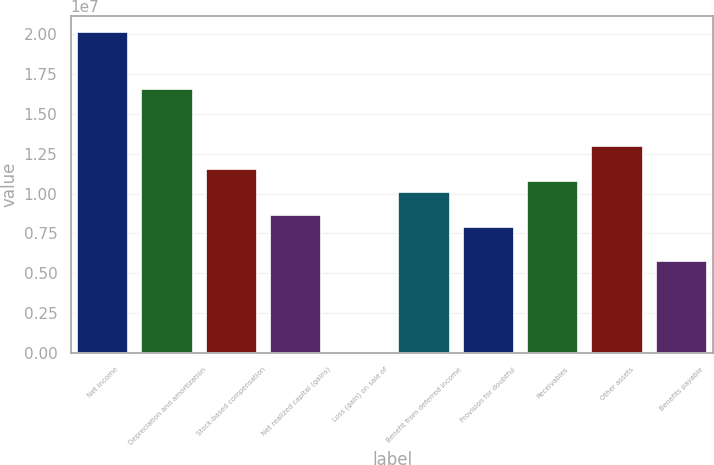Convert chart. <chart><loc_0><loc_0><loc_500><loc_500><bar_chart><fcel>Net income<fcel>Depreciation and amortization<fcel>Stock-based compensation<fcel>Net realized capital (gains)<fcel>Loss (gain) on sale of<fcel>Benefit from deferred income<fcel>Provision for doubtful<fcel>Receivables<fcel>Other assets<fcel>Benefits payable<nl><fcel>2.01512e+07<fcel>1.65528e+07<fcel>1.15151e+07<fcel>8.63636e+06<fcel>228<fcel>1.00757e+07<fcel>7.91668e+06<fcel>1.07954e+07<fcel>1.29544e+07<fcel>5.75765e+06<nl></chart> 